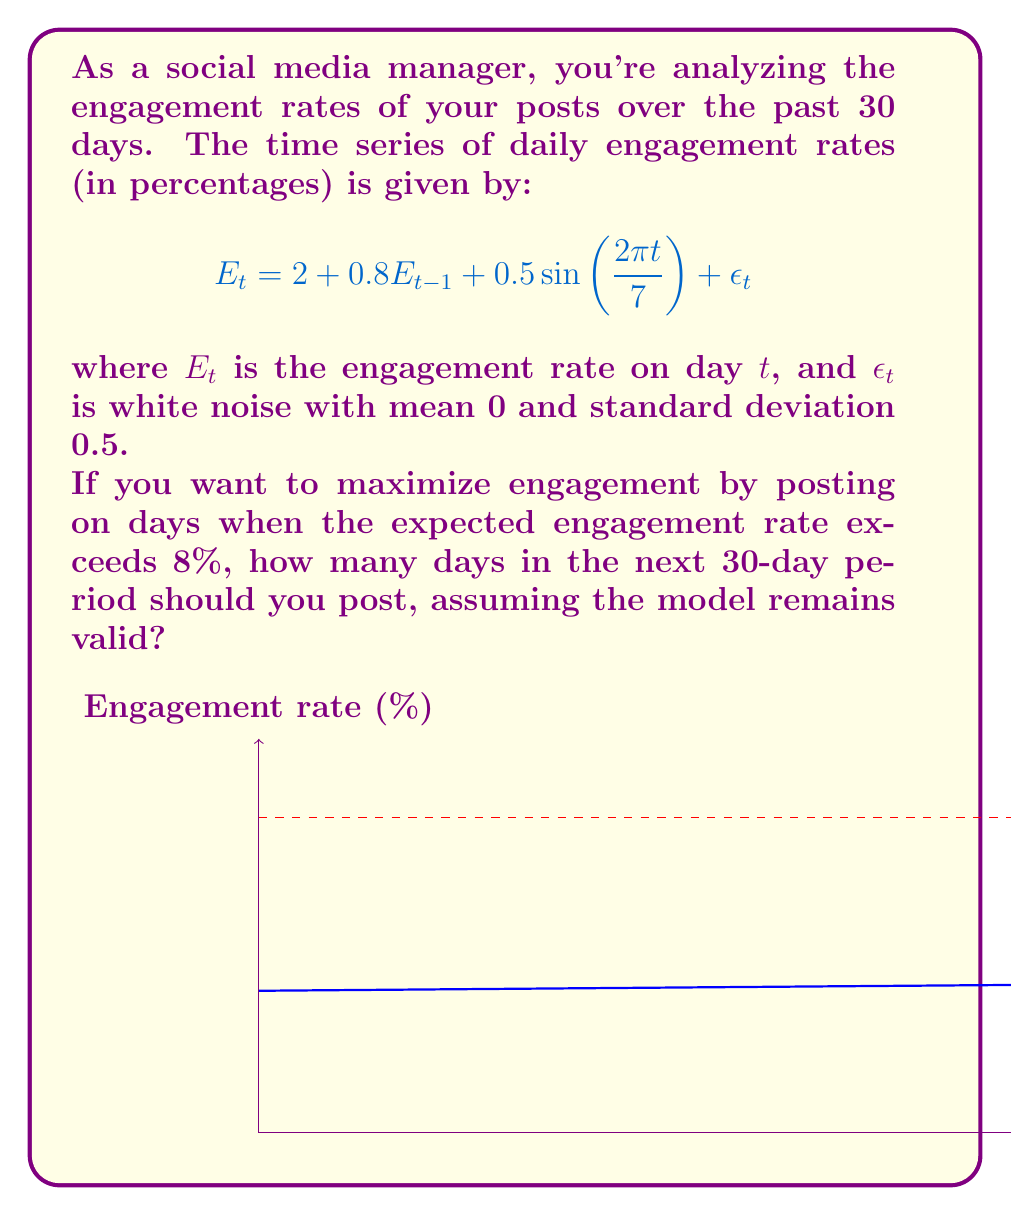Give your solution to this math problem. Let's approach this step-by-step:

1) First, we need to find the steady-state mean of the engagement rate. Let $\mu = E[E_t]$. Then:

   $$\mu = 2 + 0.8\mu + 0.5E[\sin(\frac{2\pi t}{7})] + E[\epsilon_t]$$

   Since $E[\sin(\frac{2\pi t}{7})] = 0$ over a full cycle and $E[\epsilon_t] = 0$, we have:

   $$\mu = 2 + 0.8\mu$$
   $$0.2\mu = 2$$
   $$\mu = 10$$

2) Now, the expected engagement rate on day $t$ is:

   $$E[E_t] = 2 + 0.8\mu + 0.5\sin(\frac{2\pi t}{7})$$
   $$= 2 + 8 + 0.5\sin(\frac{2\pi t}{7})$$
   $$= 10 + 0.5\sin(\frac{2\pi t}{7})$$

3) We want to find when this exceeds 8%:

   $$10 + 0.5\sin(\frac{2\pi t}{7}) > 8$$
   $$0.5\sin(\frac{2\pi t}{7}) > -2$$
   $$\sin(\frac{2\pi t}{7}) > -4$$

4) This inequality is always true, meaning the expected engagement rate always exceeds 8%.

5) Therefore, you should post every day in the next 30-day period to maximize engagement.
Answer: 30 days 